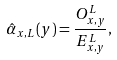Convert formula to latex. <formula><loc_0><loc_0><loc_500><loc_500>\hat { \alpha } _ { x , L } ( y ) = \frac { O _ { x , y } ^ { L } } { E _ { x , y } ^ { L } } ,</formula> 